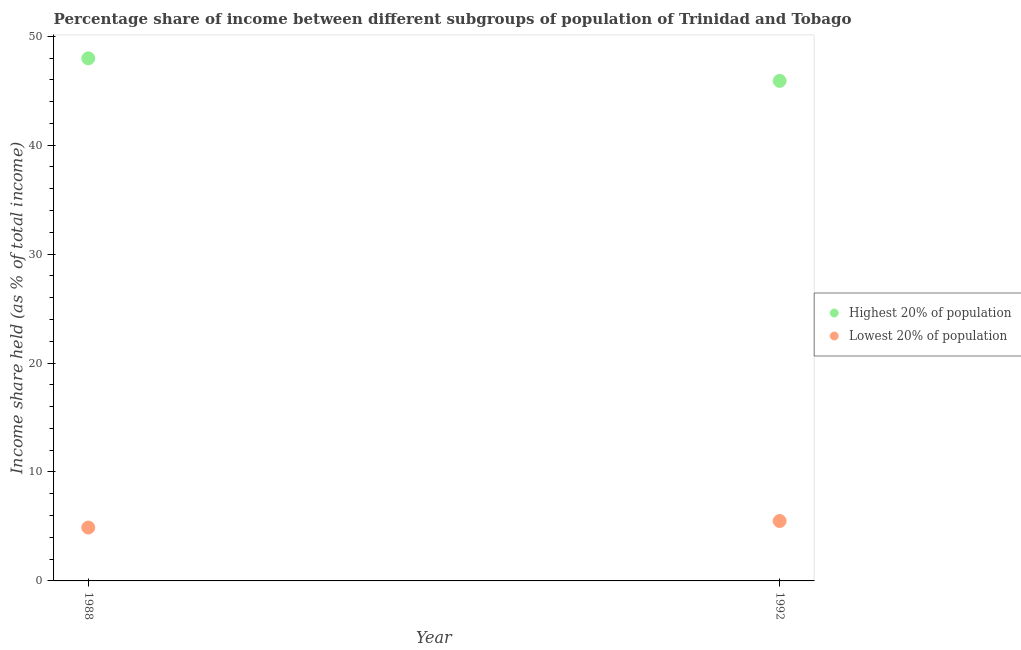How many different coloured dotlines are there?
Ensure brevity in your answer.  2. Is the number of dotlines equal to the number of legend labels?
Your answer should be compact. Yes. What is the income share held by lowest 20% of the population in 1988?
Provide a succinct answer. 4.9. Across all years, what is the minimum income share held by lowest 20% of the population?
Ensure brevity in your answer.  4.9. In which year was the income share held by highest 20% of the population minimum?
Your answer should be compact. 1992. What is the total income share held by highest 20% of the population in the graph?
Make the answer very short. 93.87. What is the difference between the income share held by highest 20% of the population in 1988 and that in 1992?
Ensure brevity in your answer.  2.07. What is the difference between the income share held by highest 20% of the population in 1988 and the income share held by lowest 20% of the population in 1992?
Give a very brief answer. 42.47. What is the average income share held by highest 20% of the population per year?
Offer a terse response. 46.94. In the year 1992, what is the difference between the income share held by highest 20% of the population and income share held by lowest 20% of the population?
Offer a very short reply. 40.4. What is the ratio of the income share held by highest 20% of the population in 1988 to that in 1992?
Your response must be concise. 1.05. Does the income share held by lowest 20% of the population monotonically increase over the years?
Provide a short and direct response. Yes. Is the income share held by highest 20% of the population strictly greater than the income share held by lowest 20% of the population over the years?
Keep it short and to the point. Yes. How many years are there in the graph?
Keep it short and to the point. 2. What is the difference between two consecutive major ticks on the Y-axis?
Give a very brief answer. 10. Are the values on the major ticks of Y-axis written in scientific E-notation?
Ensure brevity in your answer.  No. Does the graph contain any zero values?
Make the answer very short. No. How many legend labels are there?
Your response must be concise. 2. How are the legend labels stacked?
Provide a succinct answer. Vertical. What is the title of the graph?
Give a very brief answer. Percentage share of income between different subgroups of population of Trinidad and Tobago. What is the label or title of the Y-axis?
Your answer should be compact. Income share held (as % of total income). What is the Income share held (as % of total income) of Highest 20% of population in 1988?
Provide a succinct answer. 47.97. What is the Income share held (as % of total income) of Highest 20% of population in 1992?
Offer a terse response. 45.9. Across all years, what is the maximum Income share held (as % of total income) in Highest 20% of population?
Your answer should be compact. 47.97. Across all years, what is the maximum Income share held (as % of total income) of Lowest 20% of population?
Make the answer very short. 5.5. Across all years, what is the minimum Income share held (as % of total income) of Highest 20% of population?
Make the answer very short. 45.9. Across all years, what is the minimum Income share held (as % of total income) in Lowest 20% of population?
Provide a short and direct response. 4.9. What is the total Income share held (as % of total income) in Highest 20% of population in the graph?
Offer a very short reply. 93.87. What is the total Income share held (as % of total income) of Lowest 20% of population in the graph?
Give a very brief answer. 10.4. What is the difference between the Income share held (as % of total income) of Highest 20% of population in 1988 and that in 1992?
Your response must be concise. 2.07. What is the difference between the Income share held (as % of total income) in Highest 20% of population in 1988 and the Income share held (as % of total income) in Lowest 20% of population in 1992?
Give a very brief answer. 42.47. What is the average Income share held (as % of total income) of Highest 20% of population per year?
Ensure brevity in your answer.  46.94. In the year 1988, what is the difference between the Income share held (as % of total income) of Highest 20% of population and Income share held (as % of total income) of Lowest 20% of population?
Your answer should be very brief. 43.07. In the year 1992, what is the difference between the Income share held (as % of total income) of Highest 20% of population and Income share held (as % of total income) of Lowest 20% of population?
Your answer should be compact. 40.4. What is the ratio of the Income share held (as % of total income) of Highest 20% of population in 1988 to that in 1992?
Give a very brief answer. 1.05. What is the ratio of the Income share held (as % of total income) in Lowest 20% of population in 1988 to that in 1992?
Ensure brevity in your answer.  0.89. What is the difference between the highest and the second highest Income share held (as % of total income) of Highest 20% of population?
Your answer should be compact. 2.07. What is the difference between the highest and the lowest Income share held (as % of total income) in Highest 20% of population?
Provide a short and direct response. 2.07. 